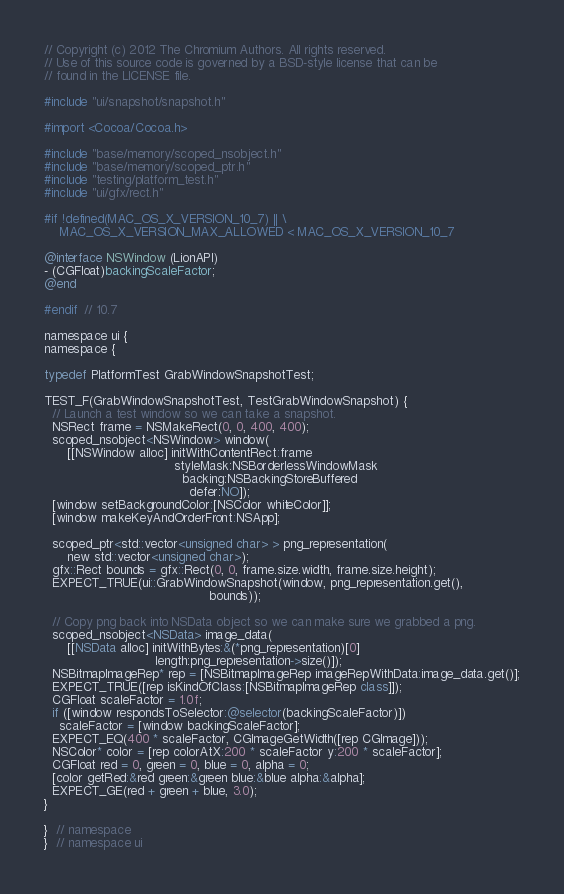Convert code to text. <code><loc_0><loc_0><loc_500><loc_500><_ObjectiveC_>// Copyright (c) 2012 The Chromium Authors. All rights reserved.
// Use of this source code is governed by a BSD-style license that can be
// found in the LICENSE file.

#include "ui/snapshot/snapshot.h"

#import <Cocoa/Cocoa.h>

#include "base/memory/scoped_nsobject.h"
#include "base/memory/scoped_ptr.h"
#include "testing/platform_test.h"
#include "ui/gfx/rect.h"

#if !defined(MAC_OS_X_VERSION_10_7) || \
    MAC_OS_X_VERSION_MAX_ALLOWED < MAC_OS_X_VERSION_10_7

@interface NSWindow (LionAPI)
- (CGFloat)backingScaleFactor;
@end

#endif  // 10.7

namespace ui {
namespace {

typedef PlatformTest GrabWindowSnapshotTest;

TEST_F(GrabWindowSnapshotTest, TestGrabWindowSnapshot) {
  // Launch a test window so we can take a snapshot.
  NSRect frame = NSMakeRect(0, 0, 400, 400);
  scoped_nsobject<NSWindow> window(
      [[NSWindow alloc] initWithContentRect:frame
                                  styleMask:NSBorderlessWindowMask
                                    backing:NSBackingStoreBuffered
                                      defer:NO]);
  [window setBackgroundColor:[NSColor whiteColor]];
  [window makeKeyAndOrderFront:NSApp];

  scoped_ptr<std::vector<unsigned char> > png_representation(
      new std::vector<unsigned char>);
  gfx::Rect bounds = gfx::Rect(0, 0, frame.size.width, frame.size.height);
  EXPECT_TRUE(ui::GrabWindowSnapshot(window, png_representation.get(),
                                           bounds));

  // Copy png back into NSData object so we can make sure we grabbed a png.
  scoped_nsobject<NSData> image_data(
      [[NSData alloc] initWithBytes:&(*png_representation)[0]
                             length:png_representation->size()]);
  NSBitmapImageRep* rep = [NSBitmapImageRep imageRepWithData:image_data.get()];
  EXPECT_TRUE([rep isKindOfClass:[NSBitmapImageRep class]]);
  CGFloat scaleFactor = 1.0f;
  if ([window respondsToSelector:@selector(backingScaleFactor)])
    scaleFactor = [window backingScaleFactor];
  EXPECT_EQ(400 * scaleFactor, CGImageGetWidth([rep CGImage]));
  NSColor* color = [rep colorAtX:200 * scaleFactor y:200 * scaleFactor];
  CGFloat red = 0, green = 0, blue = 0, alpha = 0;
  [color getRed:&red green:&green blue:&blue alpha:&alpha];
  EXPECT_GE(red + green + blue, 3.0);
}

}  // namespace
}  // namespace ui
</code> 